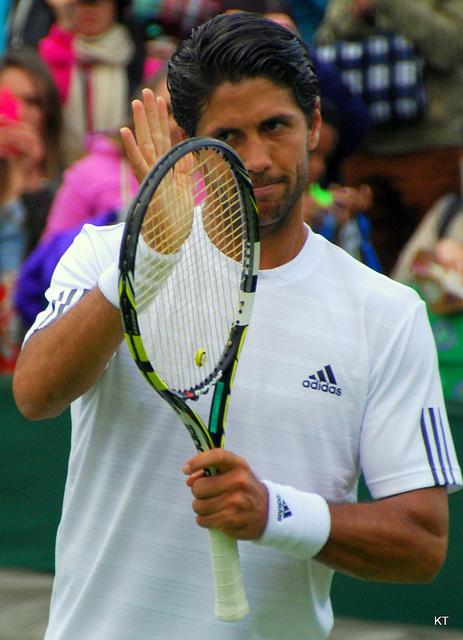What color is the logo on the man's shirt?
Write a very short answer. Blue. Is the man obese?
Short answer required. No. What color is the man's shirt?
Write a very short answer. White. What sport is he playing?
Short answer required. Tennis. What brand of clothing is he wearing?
Concise answer only. Adidas. 